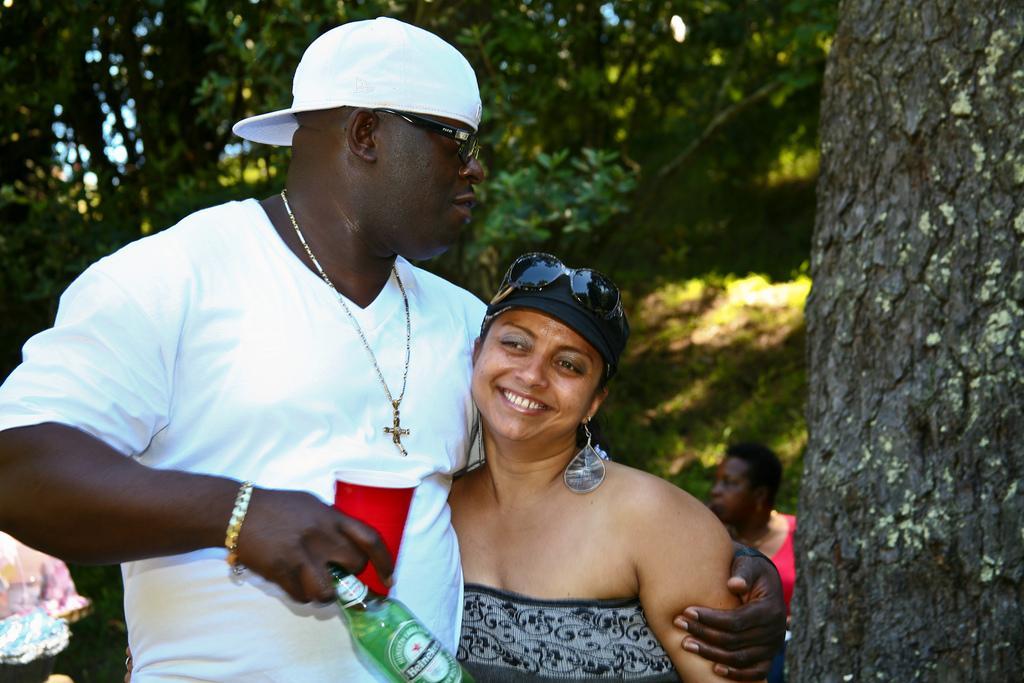Please provide a concise description of this image. In this image we can see three people standing, one man with white cap holding objects and holding a woman. There are two objects on the bottom left side of the image, one tree truck on the right side of the image, some trees in the background and some grass on the ground. 